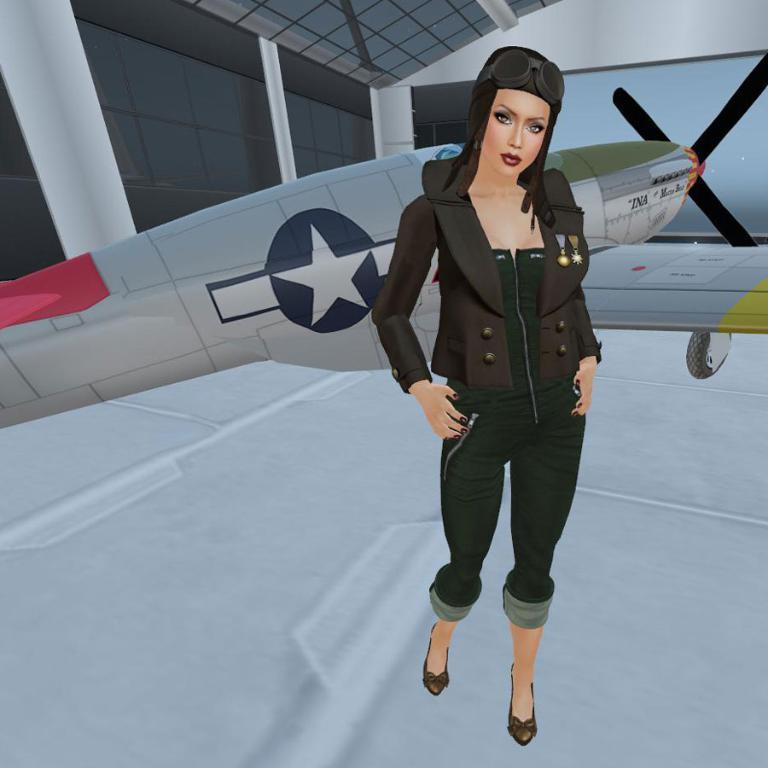Could you give a brief overview of what you see in this image? This is an animated picture. In this picture, we can see a woman standing on the floor. In the background, there is an aircraft, wall and glass objects. 